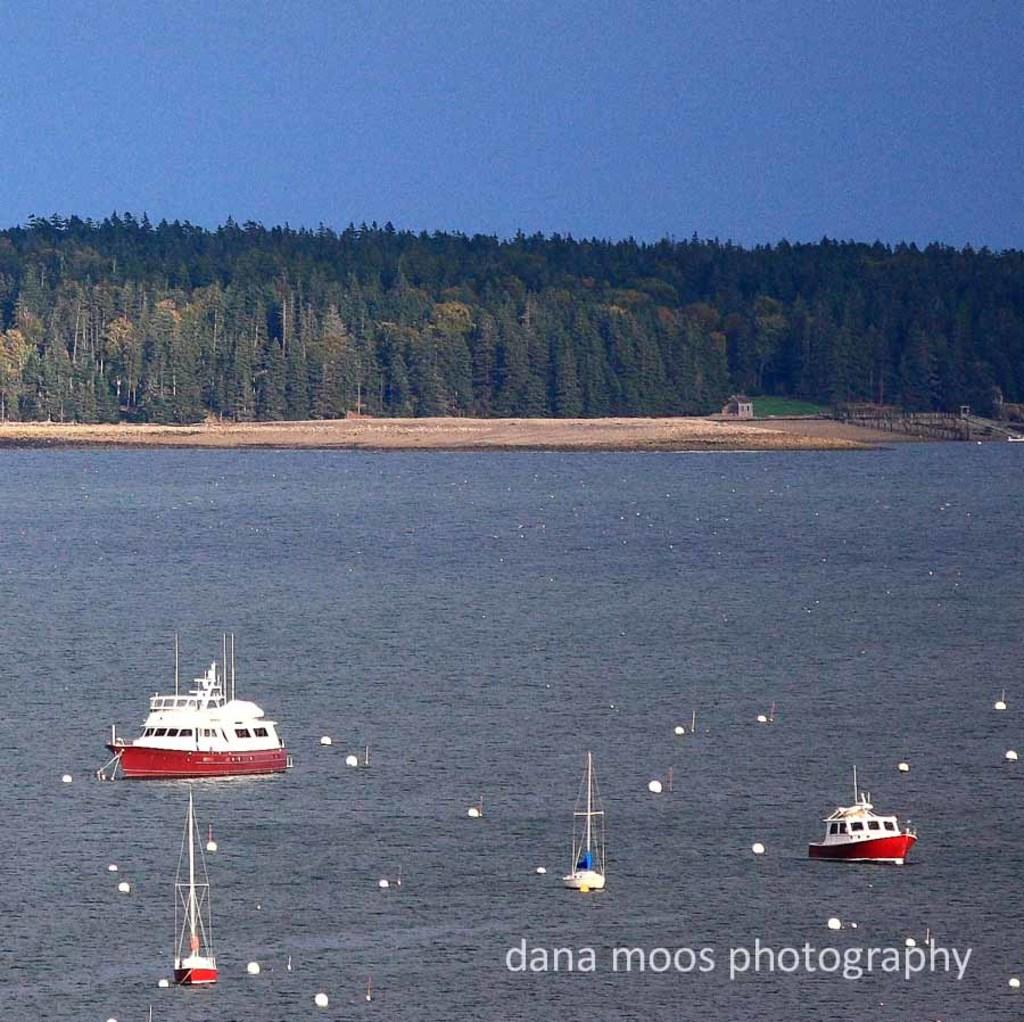<image>
Relay a brief, clear account of the picture shown. The water and a few boats can be seen with a dana moos photography watermark in the corner. 